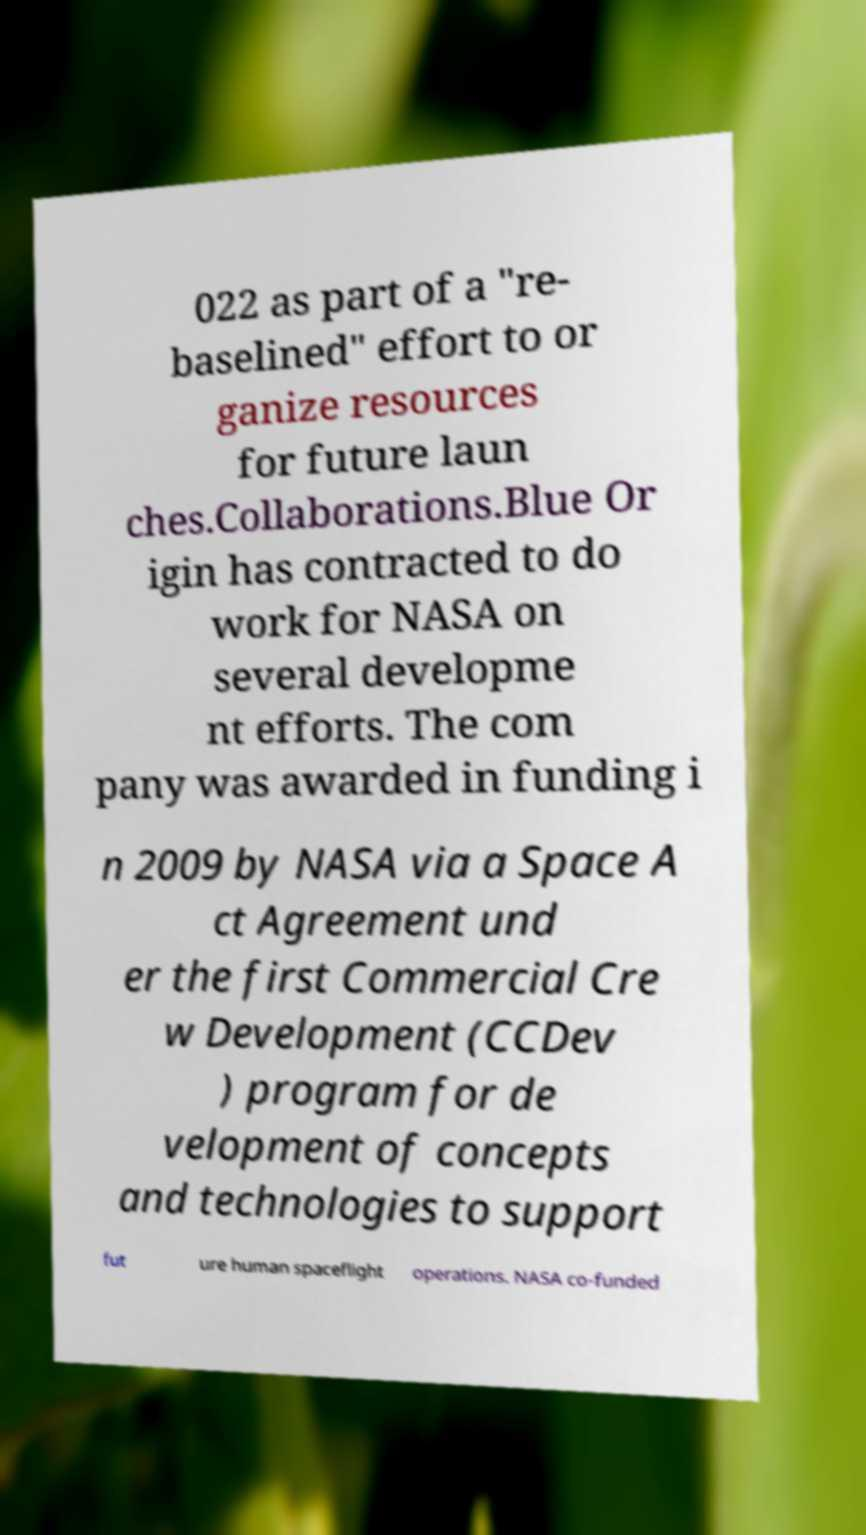I need the written content from this picture converted into text. Can you do that? 022 as part of a "re- baselined" effort to or ganize resources for future laun ches.Collaborations.Blue Or igin has contracted to do work for NASA on several developme nt efforts. The com pany was awarded in funding i n 2009 by NASA via a Space A ct Agreement und er the first Commercial Cre w Development (CCDev ) program for de velopment of concepts and technologies to support fut ure human spaceflight operations. NASA co-funded 